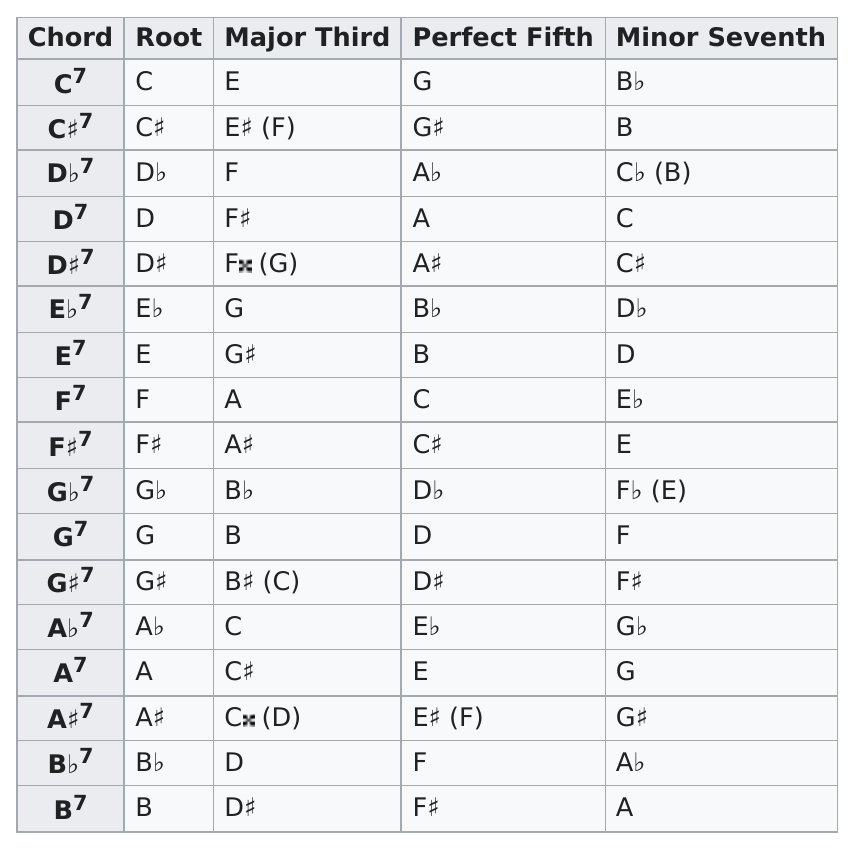Highlight a few significant elements in this photo. You can make a total of 17 thirds on a seventh form chord. The chord with its perfect fifth as C# is F#7. G♭7 is the only chord with all flat notes. There are seven chords that have a root note that is not based on a sharp or flat note. Please name the note that appears last on the minor seventh column of the table. 